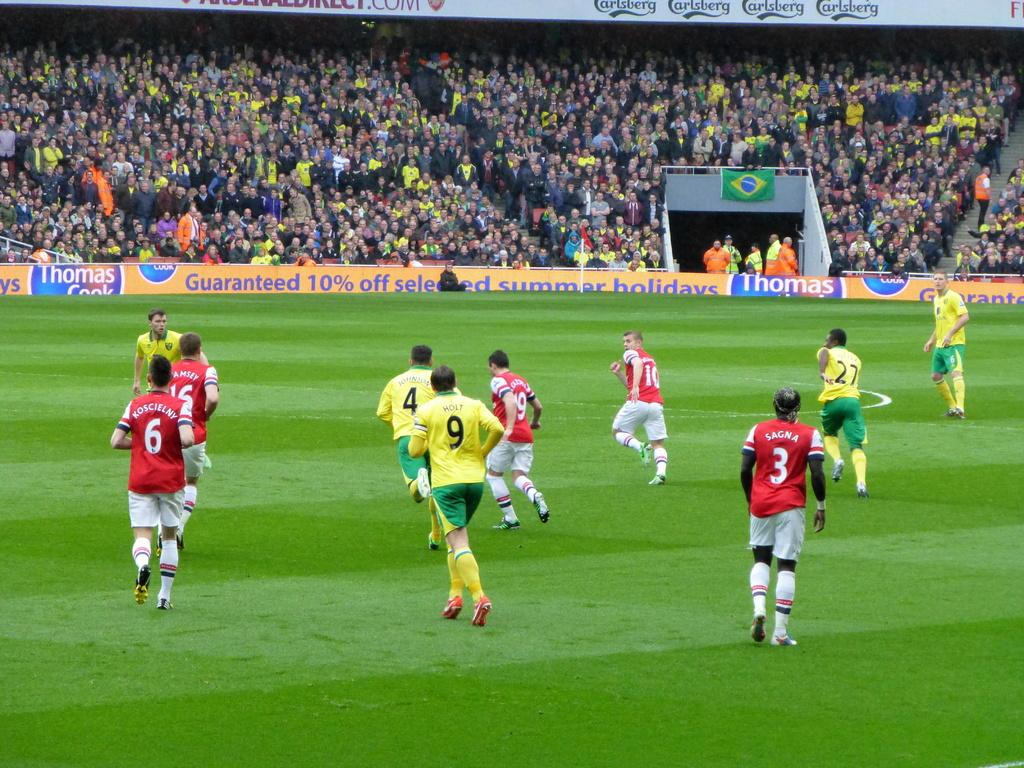<image>
Summarize the visual content of the image. A soccer field with a banner for a guaranteed 10% off advertisement 